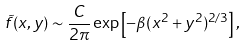<formula> <loc_0><loc_0><loc_500><loc_500>\tilde { f } ( x , y ) \sim \frac { C } { 2 \pi } \exp \left [ - \beta ( x ^ { 2 } + y ^ { 2 } ) ^ { 2 / 3 } \right ] ,</formula> 